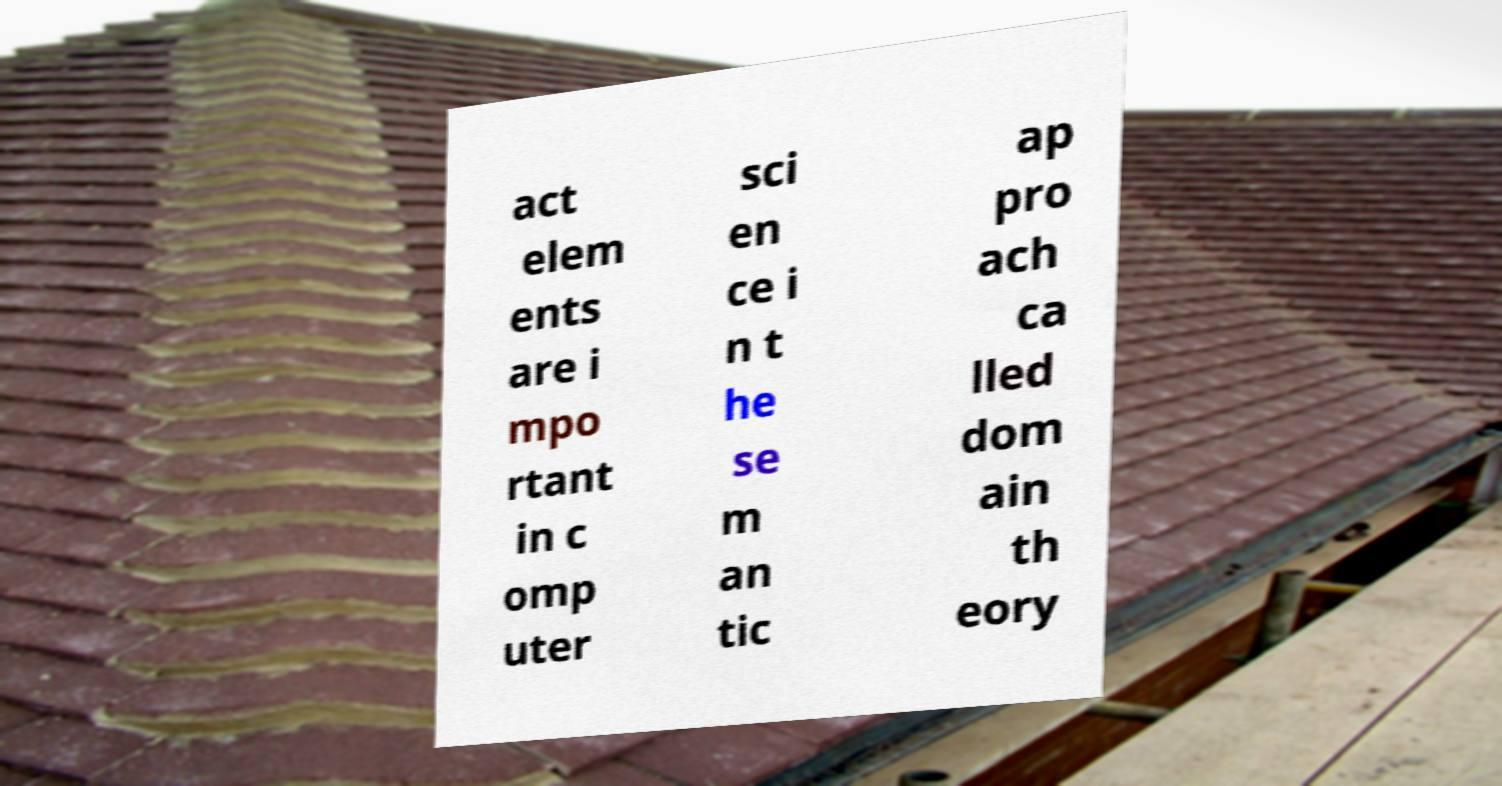What messages or text are displayed in this image? I need them in a readable, typed format. act elem ents are i mpo rtant in c omp uter sci en ce i n t he se m an tic ap pro ach ca lled dom ain th eory 